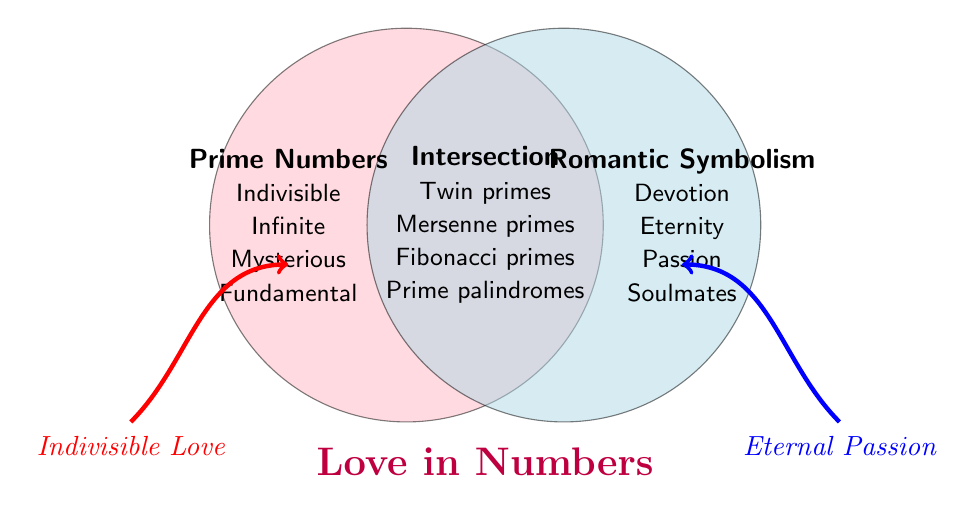What is the title of the Venn Diagram? The title of the Venn Diagram is located below the intersection and is highlighted in purple and large bold font. It reads "Love in Numbers."
Answer: Love in Numbers Which set represents the attributes of Prime Numbers? The set representing the attributes of Prime Numbers is shown on the left circle, which is colored pink and listed with terms like 'Indivisible', 'Infinite', 'Mysterious', and 'Fundamental'.
Answer: The left circle How many attributes are listed under Romantic Symbolism? The right circle of the Venn Diagram lists the attributes of Romantic Symbolism, which include 'Devotion', 'Eternity', 'Passion', and 'Soulmates'. There are four attributes in total.
Answer: Four Identify an attribute that is common between Prime Numbers and Romantic Symbolism. The intersection area of the Venn Diagram lists the common attributes between Prime Numbers and Romantic Symbolism. One of these attributes is 'Twin primes'.
Answer: Twin primes Compare the number of attributes in the intersection with those in the Prime Numbers set. The Prime Numbers set has four attributes: 'Indivisible', 'Infinite', 'Mysterious', and 'Fundamental'. The intersection has four attributes: 'Twin primes', 'Mersenne primes', 'Fibonacci primes', and 'Prime palindromes'. Both sections have an equal number of attributes.
Answer: Equal What attribute symbolizes eternity in the Venn Diagram? The attribute that symbolizes eternity is listed under the Romantic Symbolism set in the right circle. The attribute is directly labeled as 'Eternity'.
Answer: Eternity Explain the symbolism of 'Prime palindromes' in the context of the Venn Diagram. 'Prime palindromes' fall within the intersection of the Venn Diagram, symbolizing a quality that pertains to both Prime Numbers and Romantic Symbolism. Palindromes in numerics can symbolize a love that reads the same forwards and backwards, hence depicting symmetry and a form of unchanging affection or unity akin to romance.
Answer: Both How many unique themes are visually emphasized outside of the circles in the Venn Diagram? There are two arrows outside of the circles, each with a unique theme written in italic text. The left arrow highlights 'Indivisible Love', and the right arrow emphasizes 'Eternal Passion'. This makes for two unique themes.
Answer: Two Which prime number attribute suggests inseparability and why? The attribute 'Indivisible' in the Prime Numbers set suggests inseparability. In the mathematical context, prime numbers cannot be divided by any number other than 1 and themselves, symbolizing an unbreakable or inseparable nature.
Answer: Indivisible 